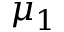<formula> <loc_0><loc_0><loc_500><loc_500>\mu _ { 1 }</formula> 